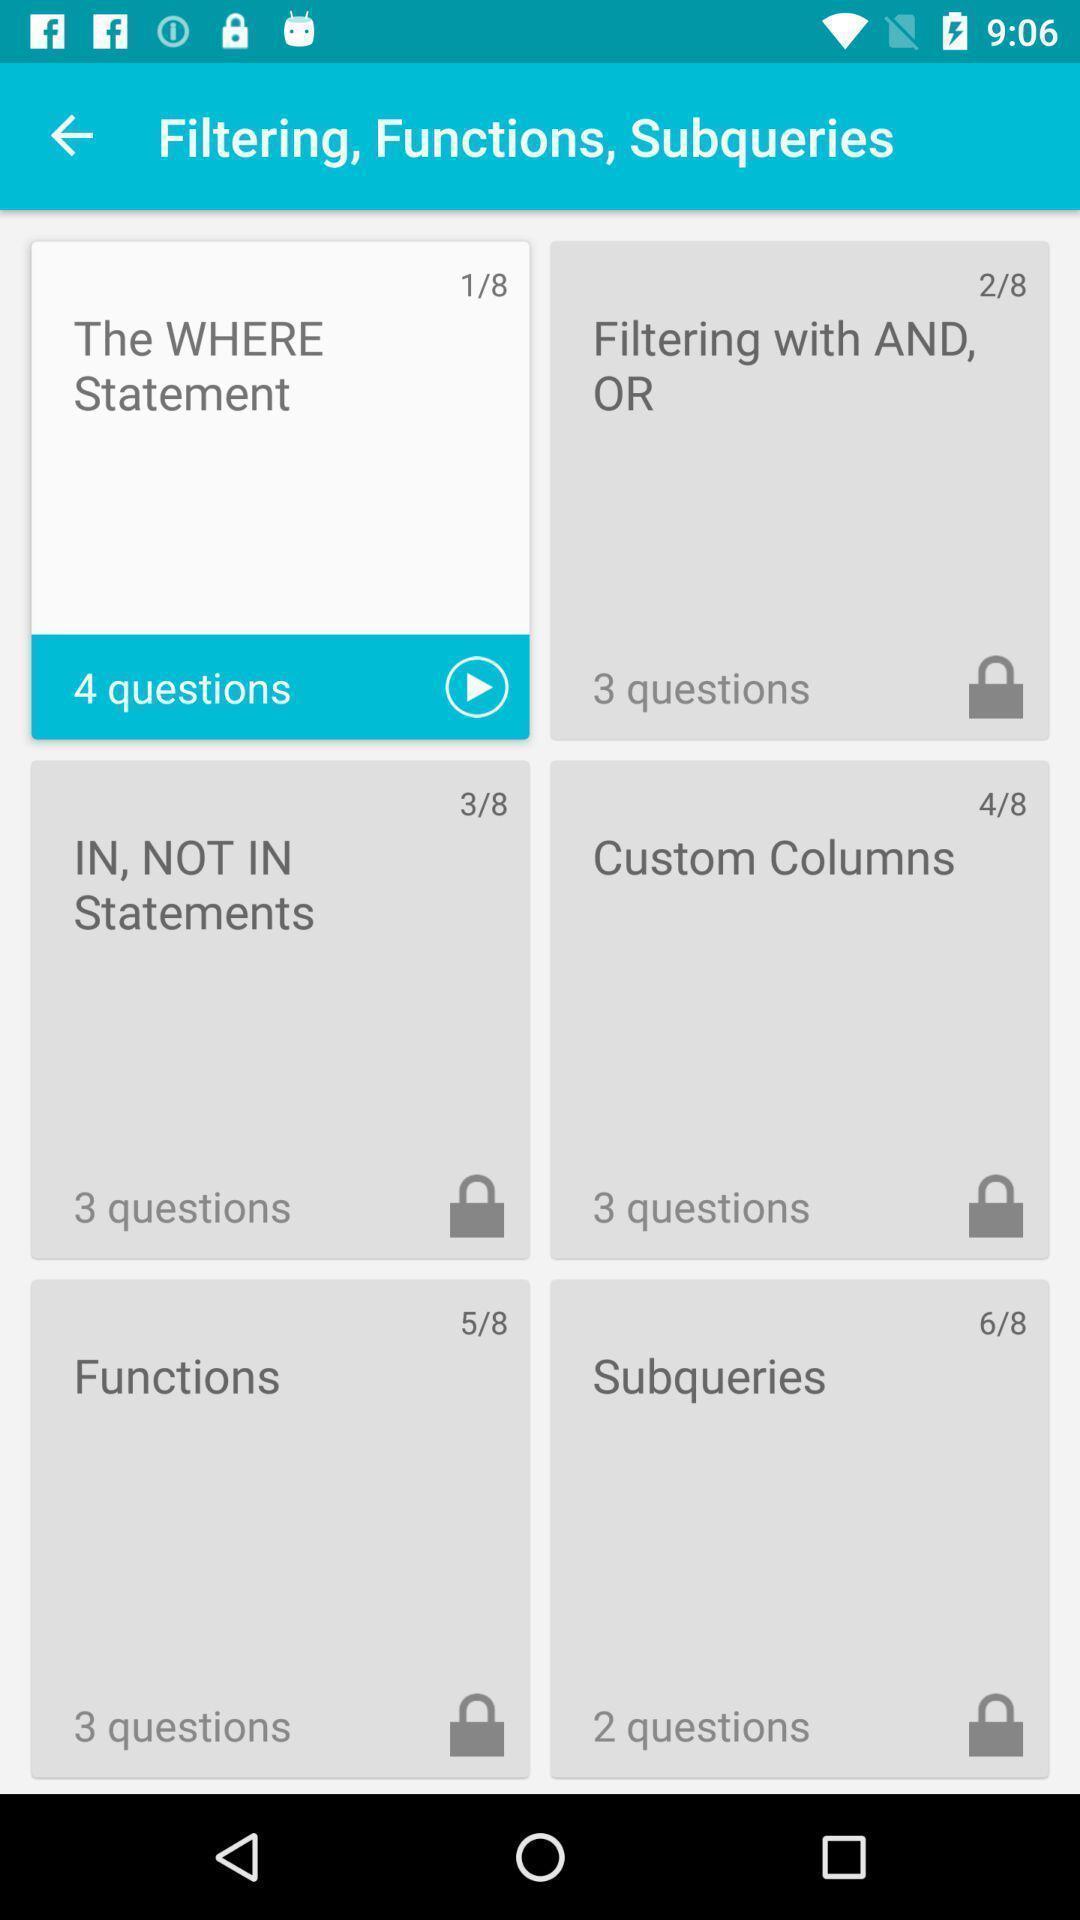Describe this image in words. Screen shows categories of creating data base. 